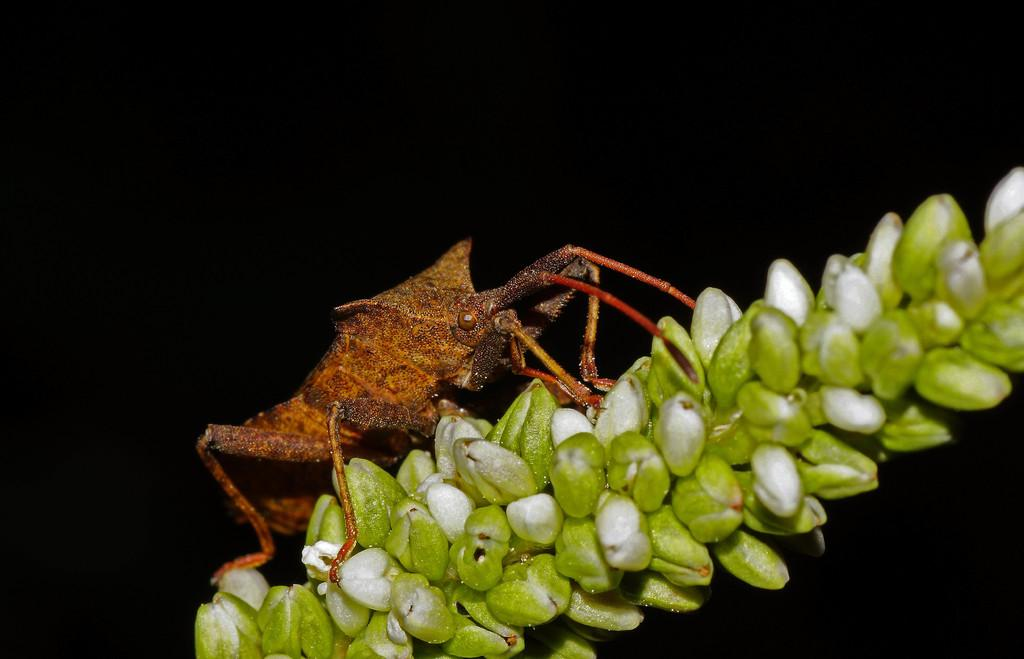What type of creature is present in the image? There is an insect in the image. Can you describe the color of the insect? The insect is brown and red in color. What is the insect resting on in the image? The insect is on a white and green object. How would you describe the overall lighting or color of the background in the image? The background of the image is dark. What type of metal is the carriage made of in the image? There is no carriage present in the image, so it is not possible to determine what type of metal it might be made of. 